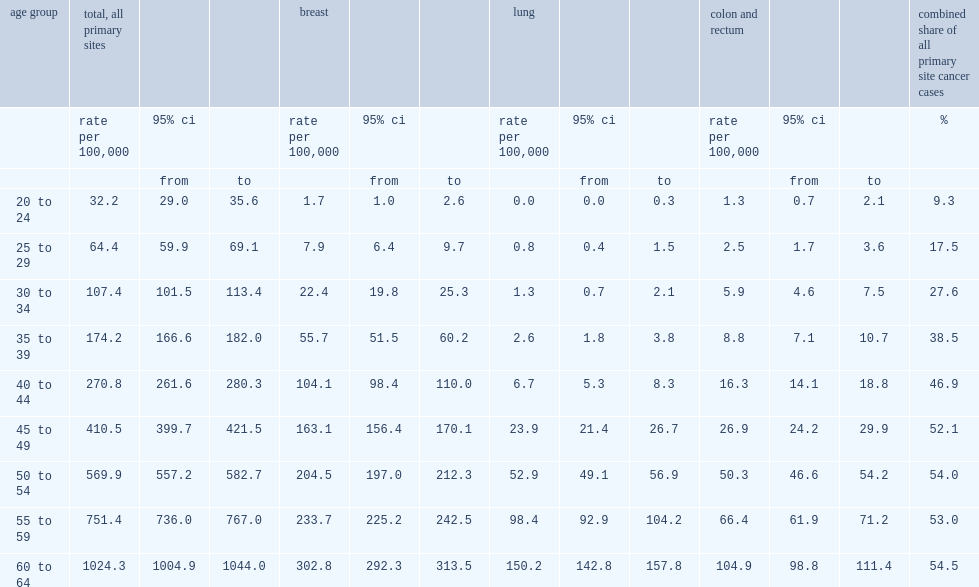What were the percentages of three cancers represented of all new cancer cases among women aged 20 to 24 and women aged 60 to 64 respectively? 9.3 54.5. 